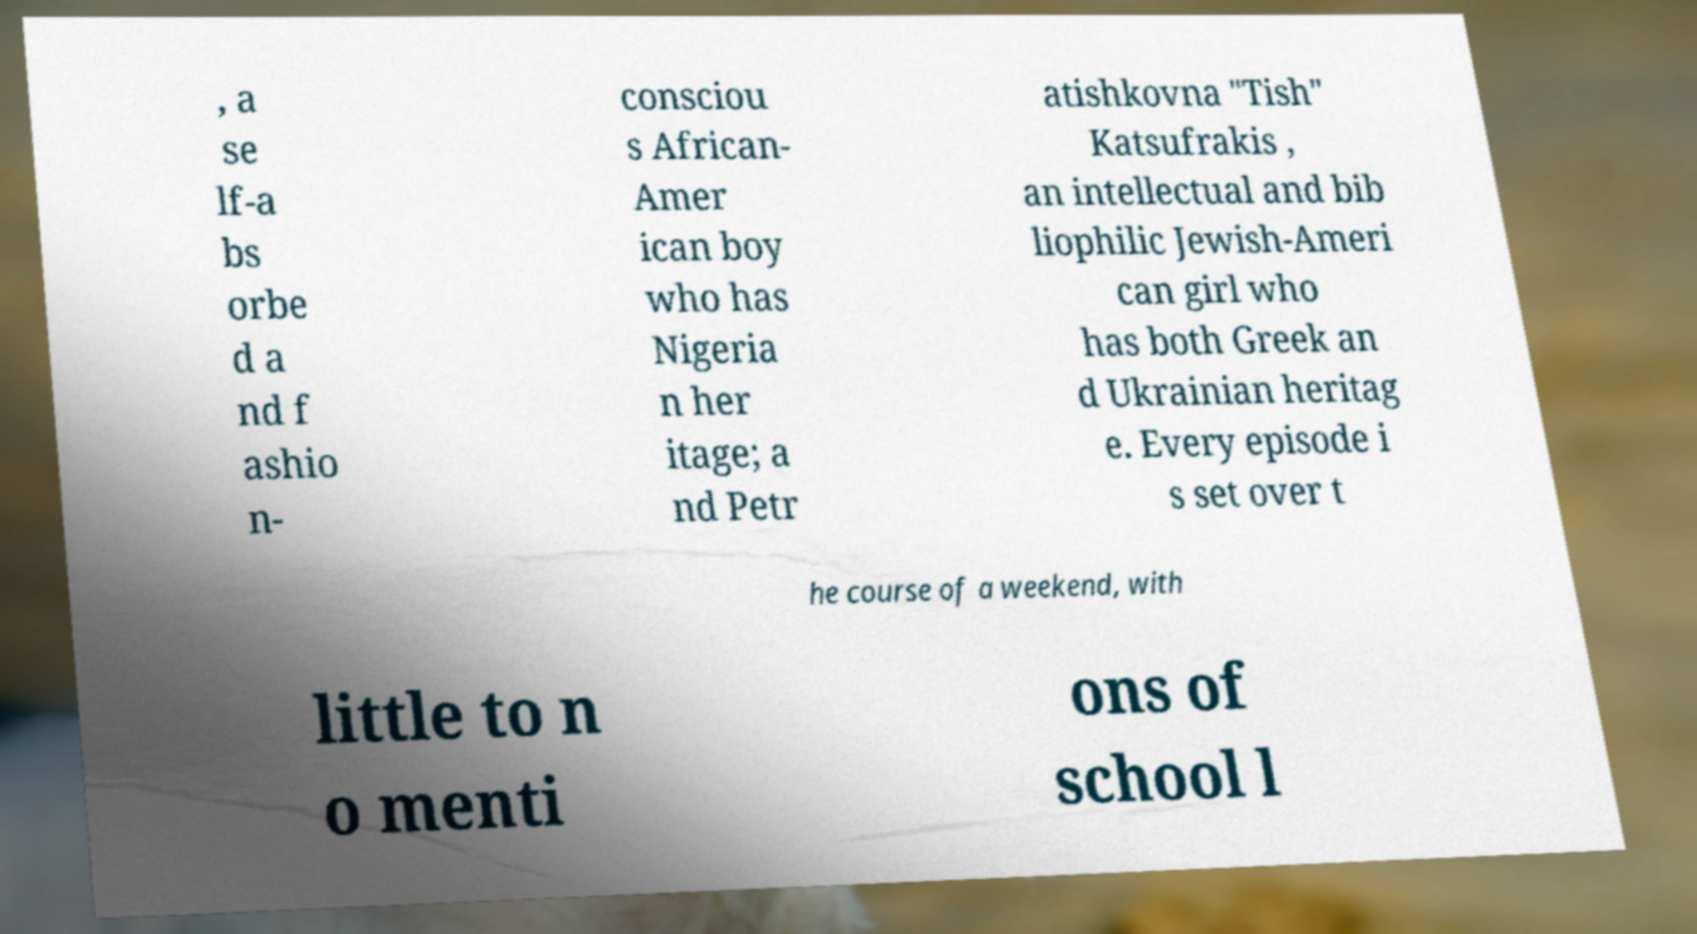Could you extract and type out the text from this image? , a se lf-a bs orbe d a nd f ashio n- consciou s African- Amer ican boy who has Nigeria n her itage; a nd Petr atishkovna "Tish" Katsufrakis , an intellectual and bib liophilic Jewish-Ameri can girl who has both Greek an d Ukrainian heritag e. Every episode i s set over t he course of a weekend, with little to n o menti ons of school l 